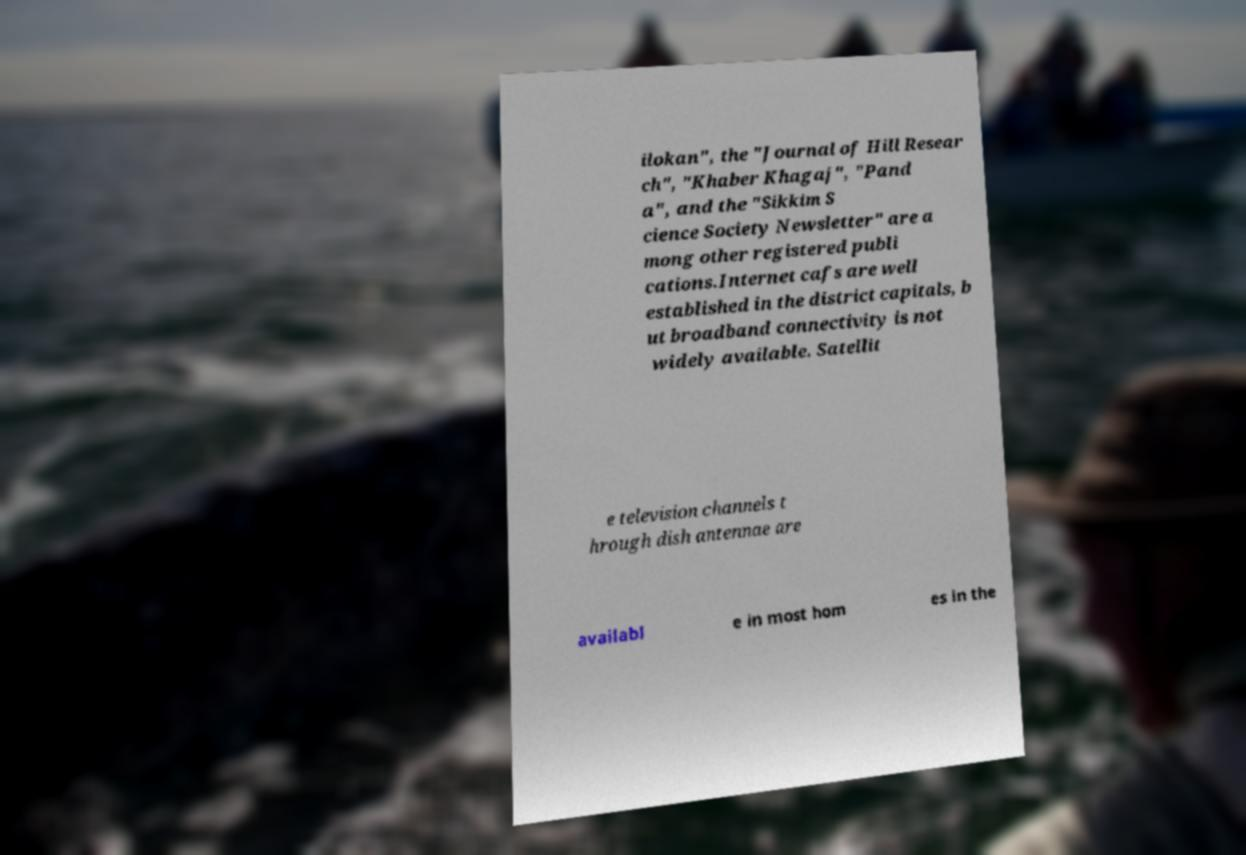For documentation purposes, I need the text within this image transcribed. Could you provide that? ilokan", the "Journal of Hill Resear ch", "Khaber Khagaj", "Pand a", and the "Sikkim S cience Society Newsletter" are a mong other registered publi cations.Internet cafs are well established in the district capitals, b ut broadband connectivity is not widely available. Satellit e television channels t hrough dish antennae are availabl e in most hom es in the 